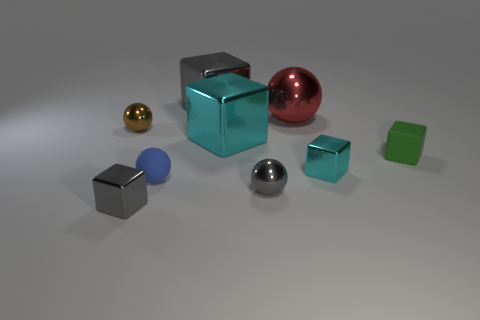Can you describe the textures of the objects presented in the image? Certainly! The objects demonstrate a variety of textures. The spheres and cubes vary between reflective and matte finishes. The reflective spheres and cubes seem to have a smooth, metallic texture, indicating they might be made of polished metals, while the matte-finished objects, like the golden sphere and the green cube, have a softer, non-reflective texture that suggests they might be composed of materials like rubber or plastic. 